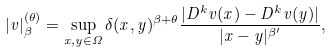<formula> <loc_0><loc_0><loc_500><loc_500>| v | _ { \beta } ^ { ( \theta ) } = \sup _ { x , y \in \Omega } \delta ( x , y ) ^ { \beta + \theta } \frac { | D ^ { k } v ( x ) - D ^ { k } v ( y ) | } { | x - y | ^ { \beta ^ { \prime } } } ,</formula> 